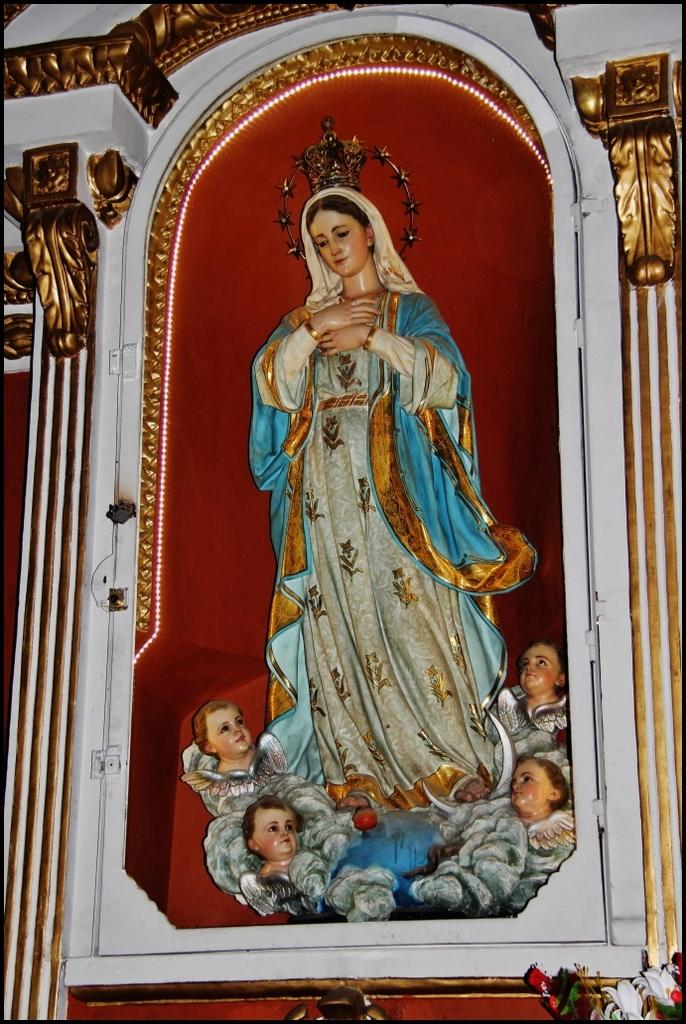What type of art is present in the image? There are sculptures in the image. What number is being offered by the scale in the image? There is no scale present in the image, so it is not possible to determine what number might be offered. 